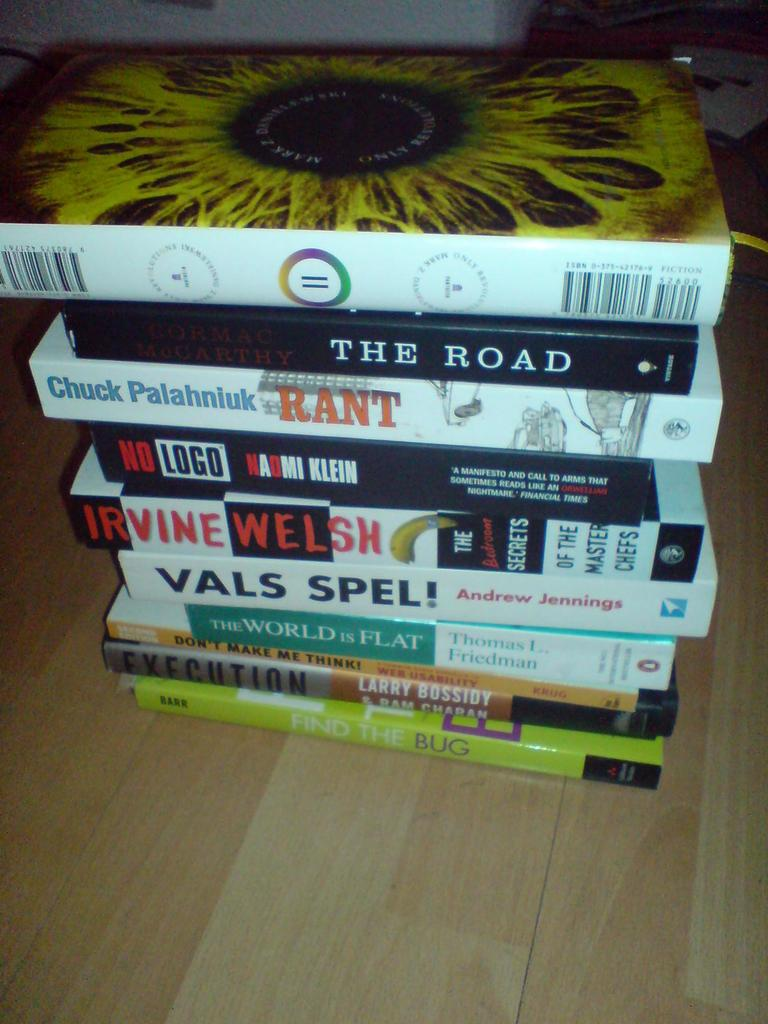<image>
Create a compact narrative representing the image presented. A large stack of books including titles such as Rant, The Road, and Find The Bug 